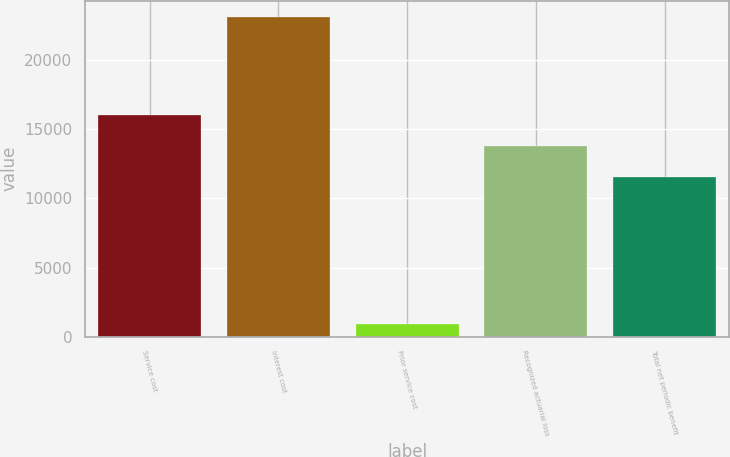Convert chart. <chart><loc_0><loc_0><loc_500><loc_500><bar_chart><fcel>Service cost<fcel>Interest cost<fcel>Prior service cost<fcel>Recognized actuarial loss<fcel>Total net periodic benefit<nl><fcel>16033.2<fcel>23163<fcel>897<fcel>13806.6<fcel>11580<nl></chart> 